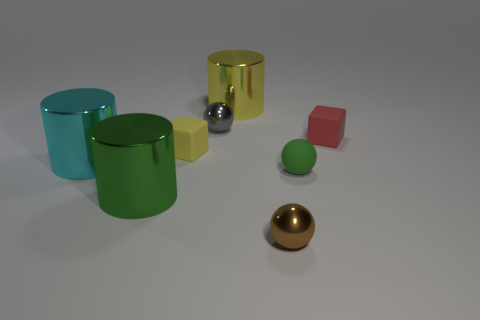Add 2 cylinders. How many objects exist? 10 Subtract all blocks. How many objects are left? 6 Add 4 cyan cylinders. How many cyan cylinders are left? 5 Add 6 small gray things. How many small gray things exist? 7 Subtract 1 red cubes. How many objects are left? 7 Subtract all large brown rubber spheres. Subtract all brown metal things. How many objects are left? 7 